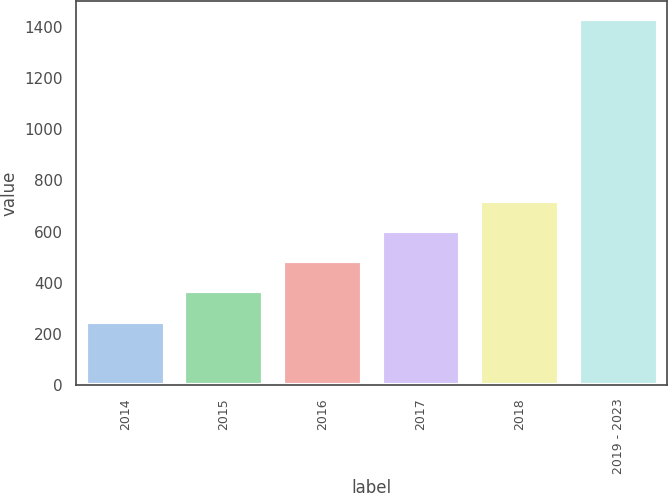Convert chart. <chart><loc_0><loc_0><loc_500><loc_500><bar_chart><fcel>2014<fcel>2015<fcel>2016<fcel>2017<fcel>2018<fcel>2019 - 2023<nl><fcel>248<fcel>366.3<fcel>484.6<fcel>602.9<fcel>721.2<fcel>1431<nl></chart> 